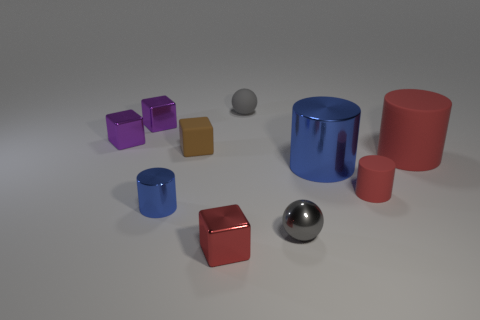Subtract 1 cylinders. How many cylinders are left? 3 Subtract all yellow blocks. Subtract all purple cylinders. How many blocks are left? 4 Subtract all cylinders. How many objects are left? 6 Subtract all red cylinders. Subtract all big cylinders. How many objects are left? 6 Add 5 big blue things. How many big blue things are left? 6 Add 9 large blue cylinders. How many large blue cylinders exist? 10 Subtract 1 brown cubes. How many objects are left? 9 